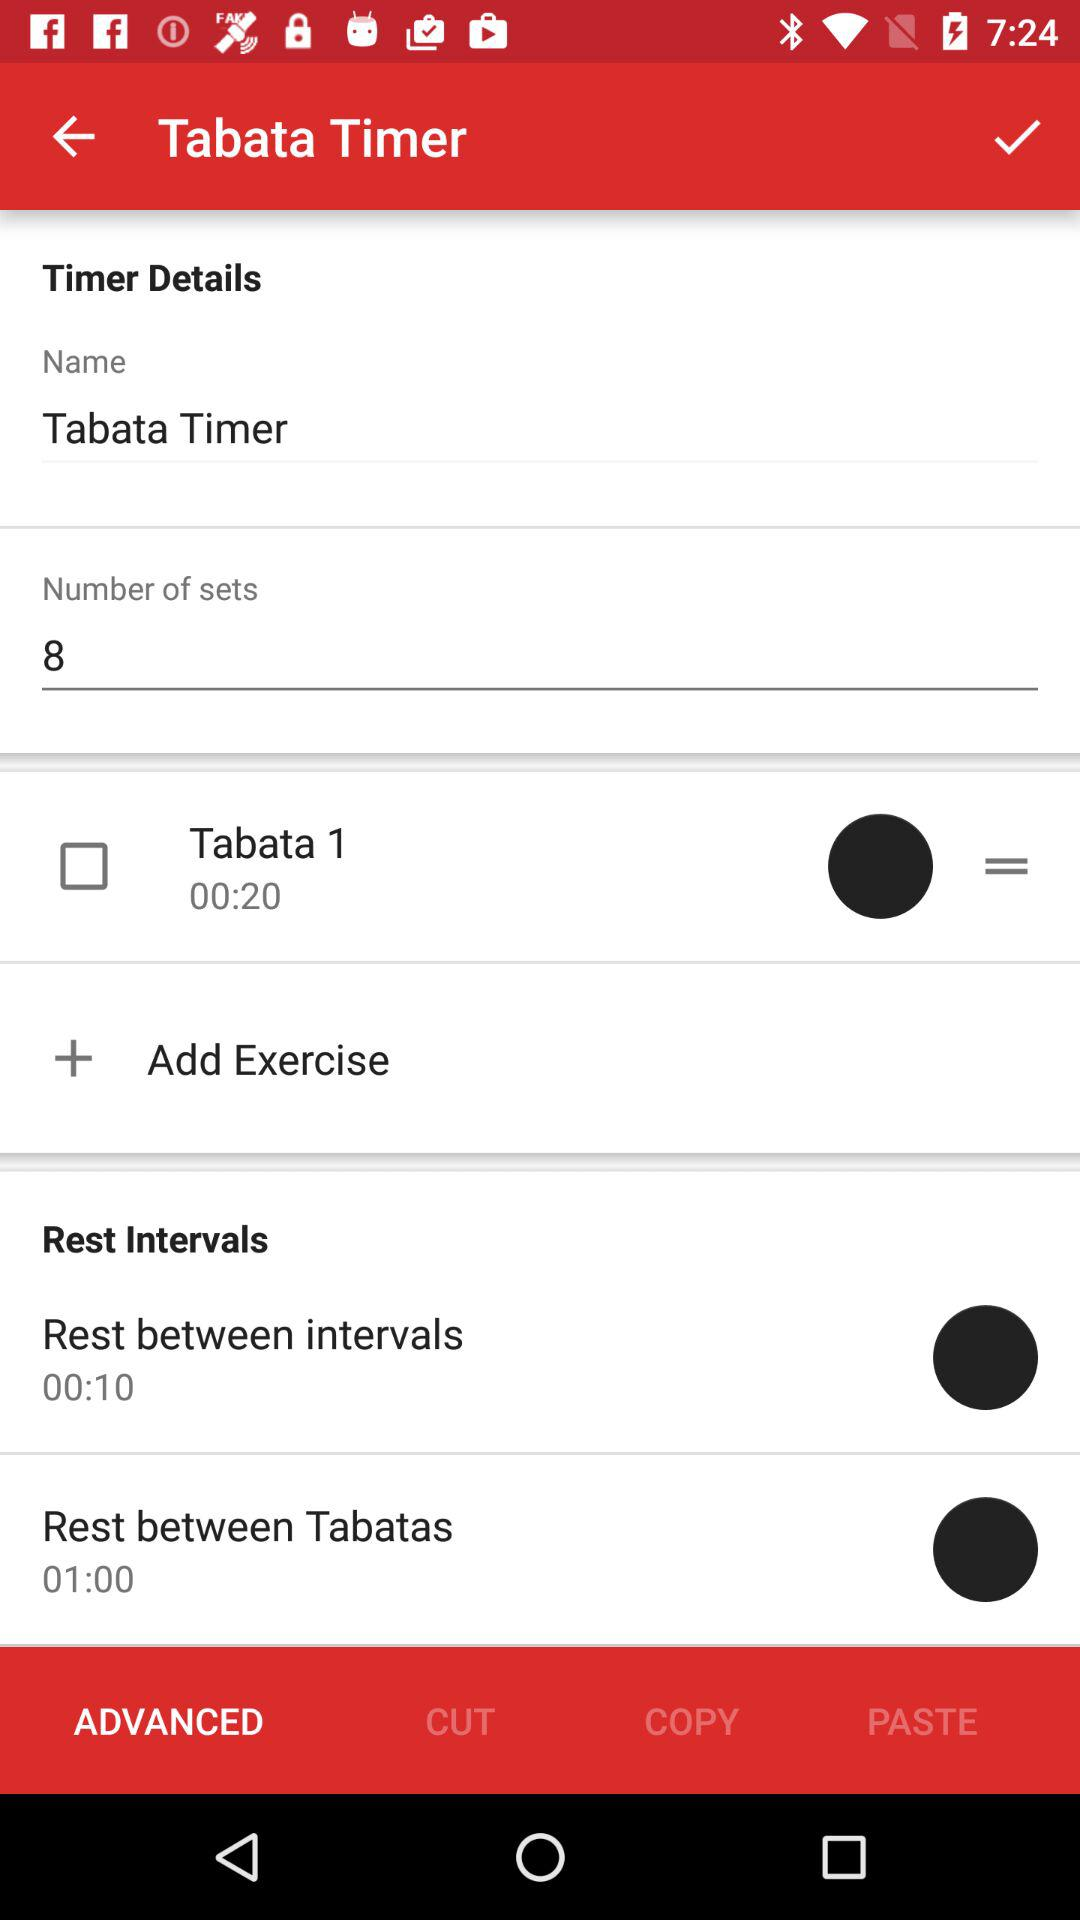Which tab is selected? The selected tab is "ADVANCED". 